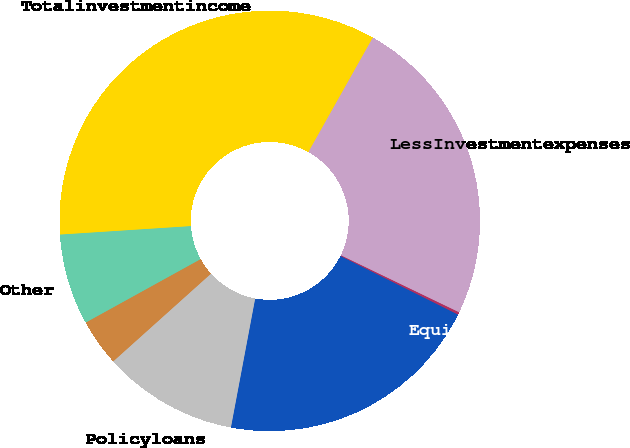Convert chart. <chart><loc_0><loc_0><loc_500><loc_500><pie_chart><fcel>Equitysecurities<fcel>Mortgageandconsumerloans<fcel>Policyloans<fcel>Unnamed: 3<fcel>Other<fcel>Totalinvestmentincome<fcel>LessInvestmentexpenses<nl><fcel>0.21%<fcel>20.6%<fcel>10.4%<fcel>3.61%<fcel>7.0%<fcel>34.19%<fcel>23.99%<nl></chart> 